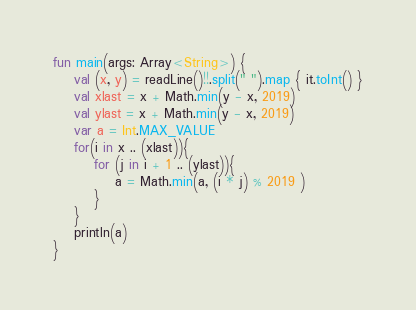Convert code to text. <code><loc_0><loc_0><loc_500><loc_500><_Kotlin_>fun main(args: Array<String>) {
    val (x, y) = readLine()!!.split(" ").map { it.toInt() }
    val xlast = x + Math.min(y - x, 2019)
    val ylast = x + Math.min(y - x, 2019)
    var a = Int.MAX_VALUE
    for(i in x .. (xlast)){
        for (j in i + 1 .. (ylast)){
            a = Math.min(a, (i * j) % 2019 )
        }
    }
    println(a)
}</code> 